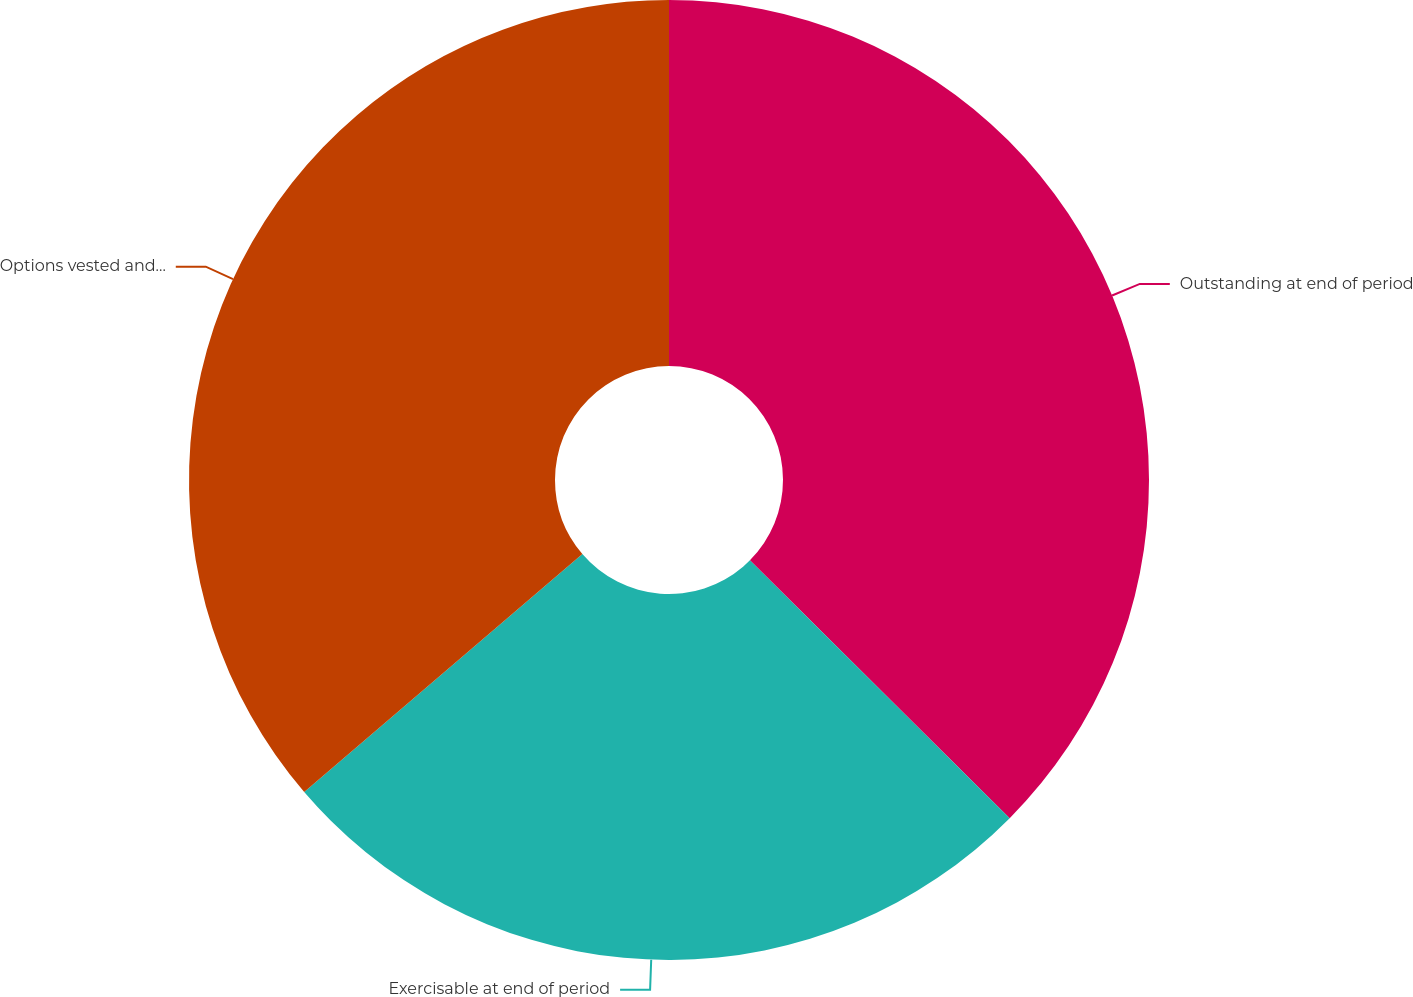Convert chart to OTSL. <chart><loc_0><loc_0><loc_500><loc_500><pie_chart><fcel>Outstanding at end of period<fcel>Exercisable at end of period<fcel>Options vested and expected to<nl><fcel>37.44%<fcel>26.3%<fcel>36.26%<nl></chart> 